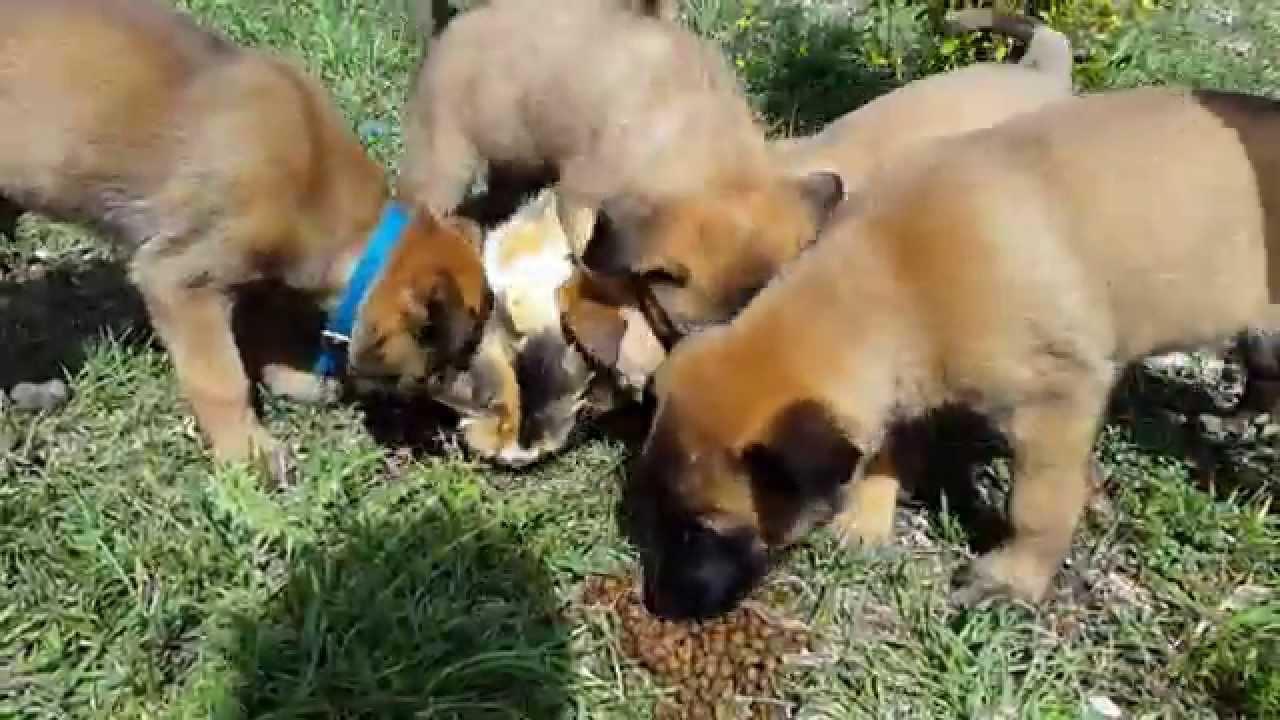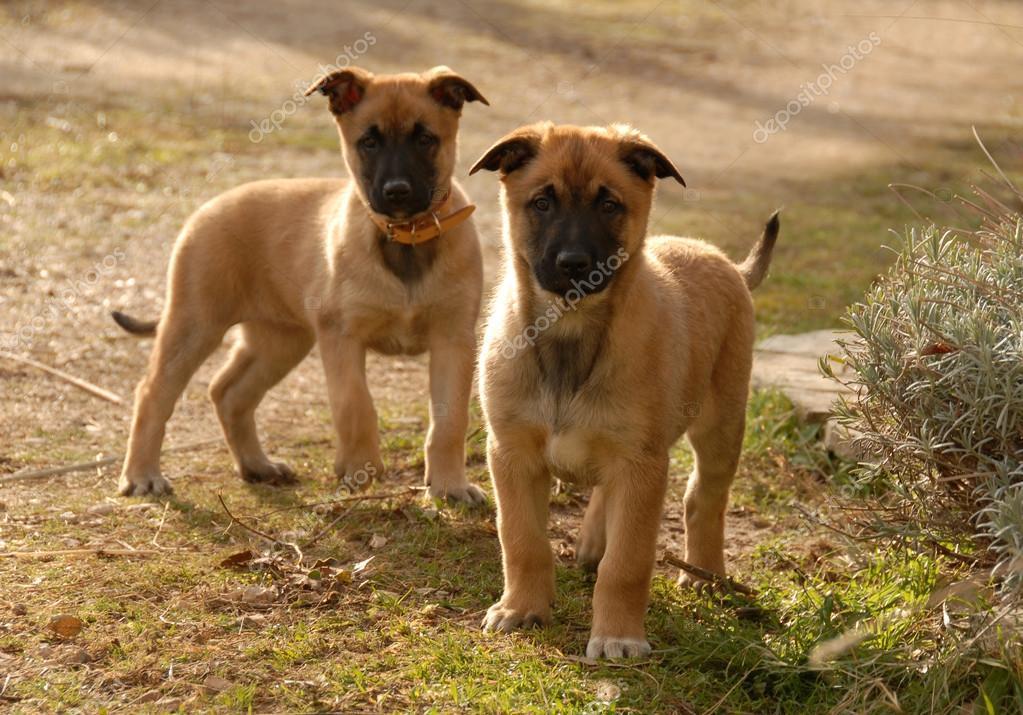The first image is the image on the left, the second image is the image on the right. For the images displayed, is the sentence "Some of the German Shepherds do not have their ears clipped." factually correct? Answer yes or no. Yes. The first image is the image on the left, the second image is the image on the right. Considering the images on both sides, is "There are at least six dogs." valid? Answer yes or no. Yes. 